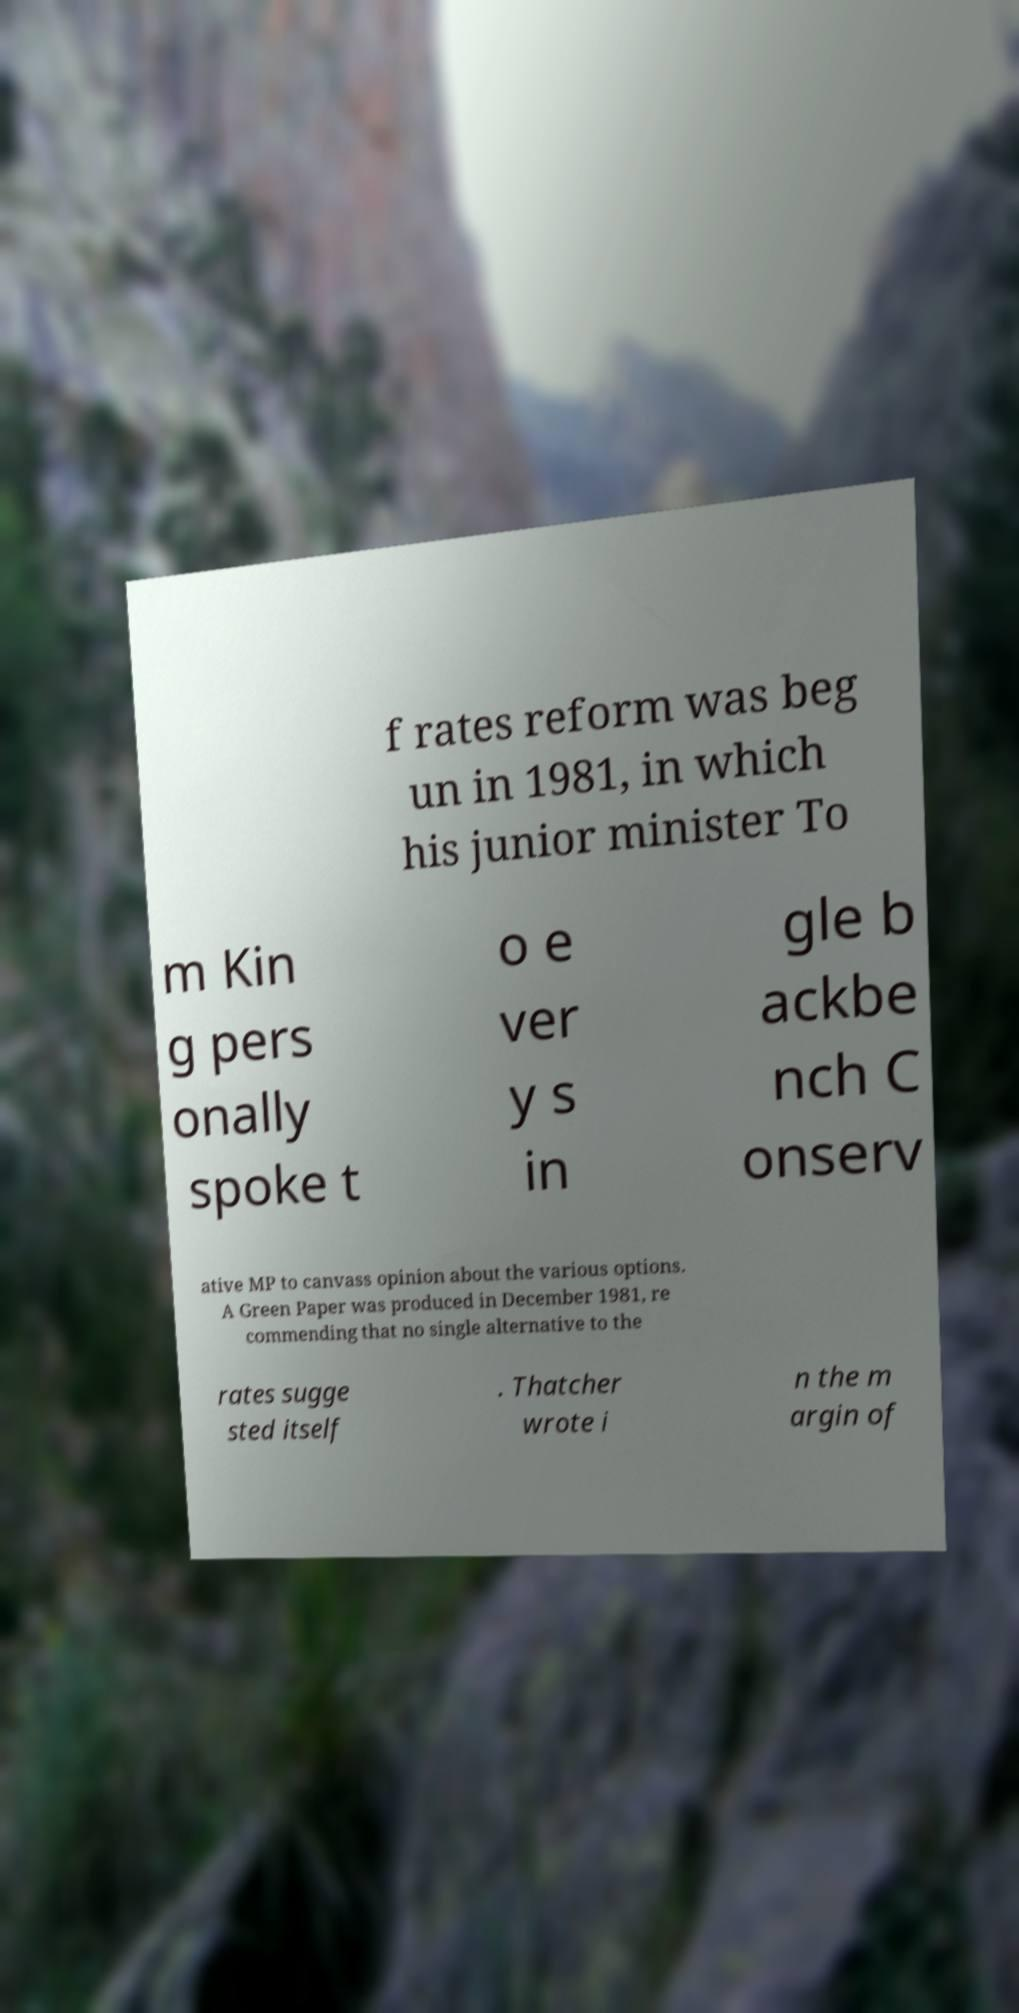Please read and relay the text visible in this image. What does it say? f rates reform was beg un in 1981, in which his junior minister To m Kin g pers onally spoke t o e ver y s in gle b ackbe nch C onserv ative MP to canvass opinion about the various options. A Green Paper was produced in December 1981, re commending that no single alternative to the rates sugge sted itself . Thatcher wrote i n the m argin of 